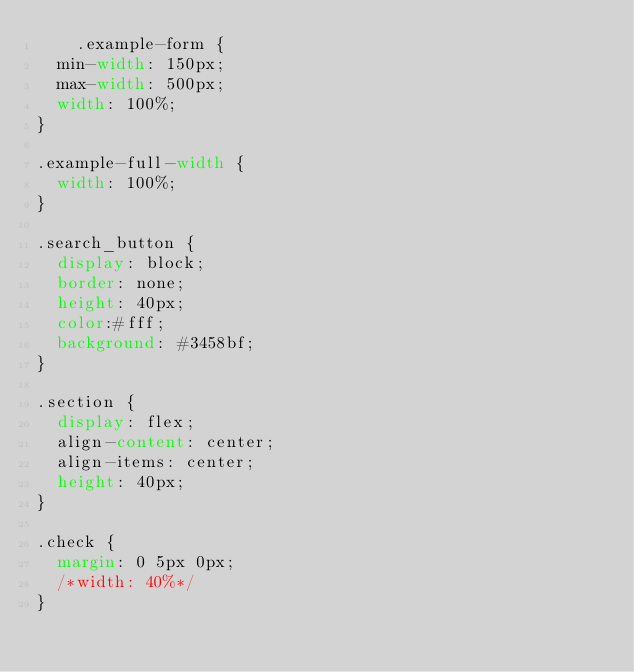Convert code to text. <code><loc_0><loc_0><loc_500><loc_500><_CSS_>    .example-form {
  min-width: 150px;
  max-width: 500px;
  width: 100%;
}

.example-full-width {
  width: 100%;
}

.search_button {
  display: block;
  border: none;
  height: 40px;
  color:#fff;
  background: #3458bf;
}

.section {
  display: flex;
  align-content: center;
  align-items: center;
  height: 40px;
}

.check {
  margin: 0 5px 0px;
  /*width: 40%*/
}
</code> 